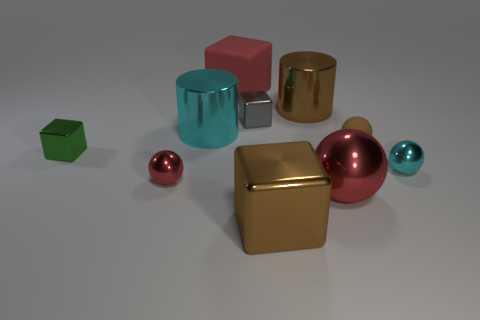Subtract 1 spheres. How many spheres are left? 3 Subtract all cylinders. How many objects are left? 8 Subtract all brown shiny spheres. Subtract all small cyan spheres. How many objects are left? 9 Add 5 large cyan cylinders. How many large cyan cylinders are left? 6 Add 1 green cubes. How many green cubes exist? 2 Subtract 1 brown cylinders. How many objects are left? 9 